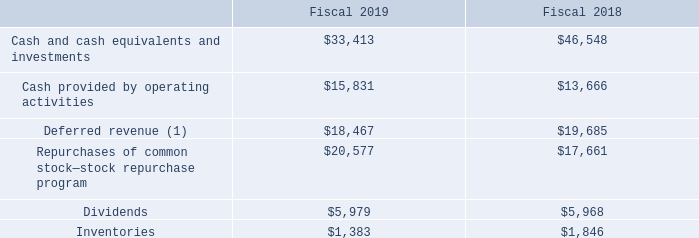Other Key Financial Measures
The following is a summary of our other key financial measures for fiscal 2019 compared with fiscal 2018 (in millions):
(1) Deferred revenue decreased primarily due to the adoption of ASC 606 in the beginning of our first quarter of fiscal 2019. See Note 2 to the Consolidated Financial Statements for the impact of this adoption.
Why did deferred revenue decrease? Due to the adoption of asc 606 in the beginning of our first quarter of fiscal 2019. What was the deferred revenue in 2019?
Answer scale should be: million. 18,467. What were the dividends in 2018?
Answer scale should be: million. 5,968. What was the change in inventories between 2018 and 2019?
Answer scale should be: million. 1,383-1,846
Answer: -463. What was the change in Cash provided by operating activities between 2018 and 2019?
Answer scale should be: million. 15,831-13,666
Answer: 2165. What was the percentage change in deferred revenue between 2018 and 2019?
Answer scale should be: percent. (18,467-19,685)/19,685
Answer: -6.19. 